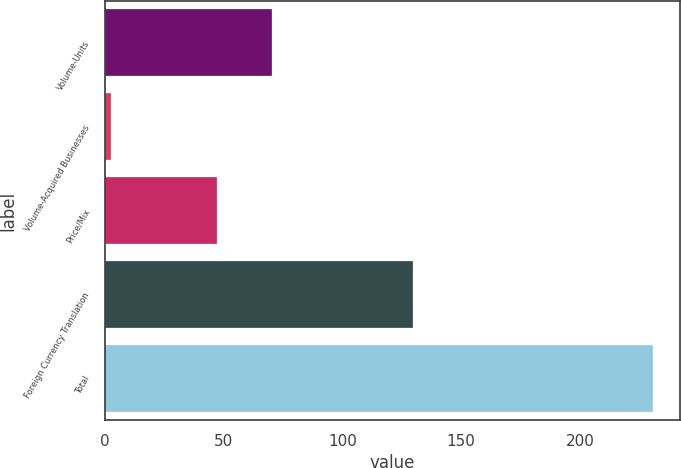Convert chart. <chart><loc_0><loc_0><loc_500><loc_500><bar_chart><fcel>Volume-Units<fcel>Volume-Acquired Businesses<fcel>Price/Mix<fcel>Foreign Currency Translation<fcel>Total<nl><fcel>70.22<fcel>2.4<fcel>47.4<fcel>129.6<fcel>230.6<nl></chart> 